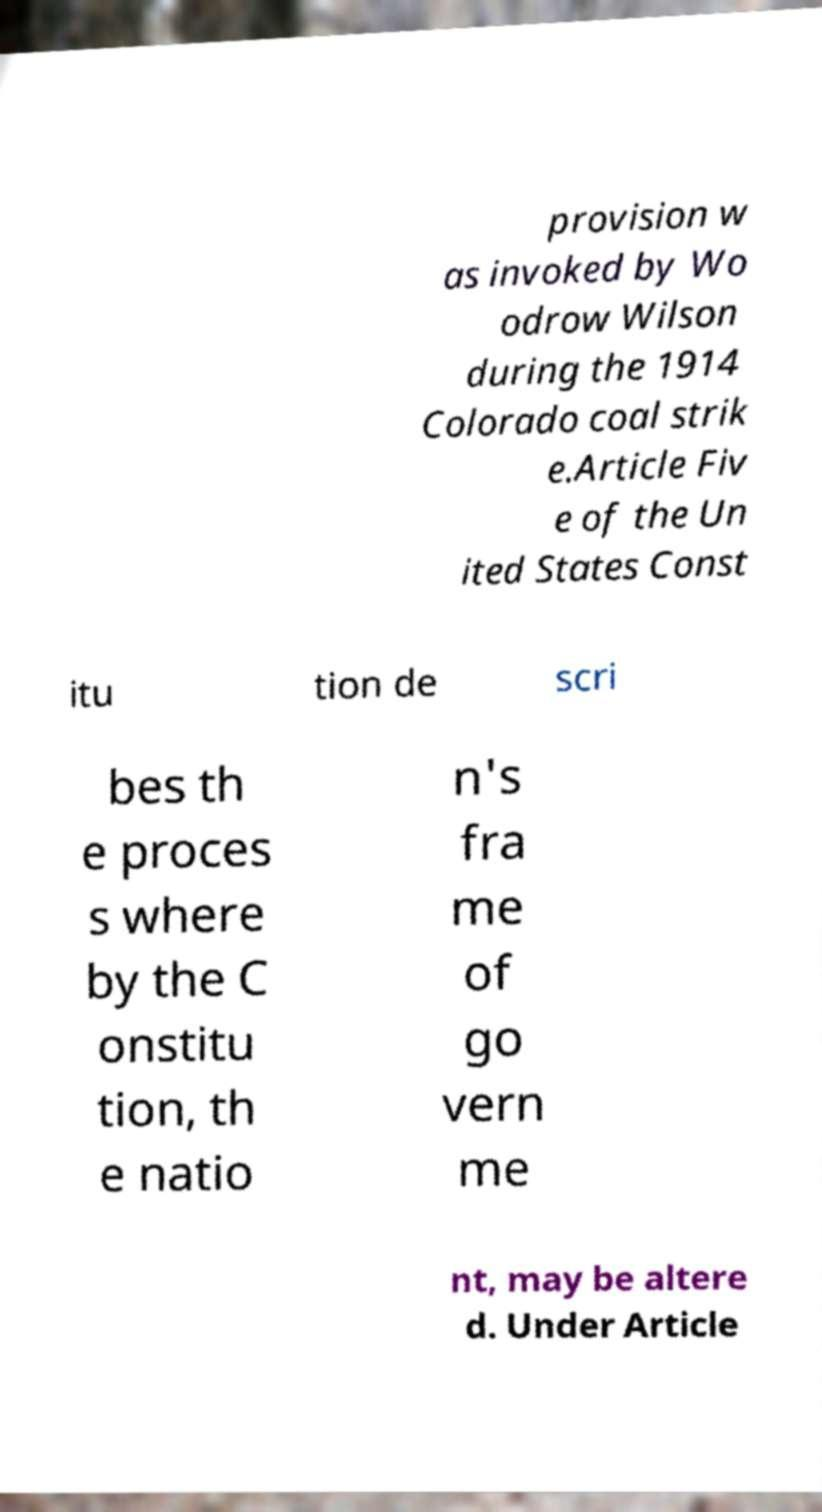Can you read and provide the text displayed in the image?This photo seems to have some interesting text. Can you extract and type it out for me? provision w as invoked by Wo odrow Wilson during the 1914 Colorado coal strik e.Article Fiv e of the Un ited States Const itu tion de scri bes th e proces s where by the C onstitu tion, th e natio n's fra me of go vern me nt, may be altere d. Under Article 